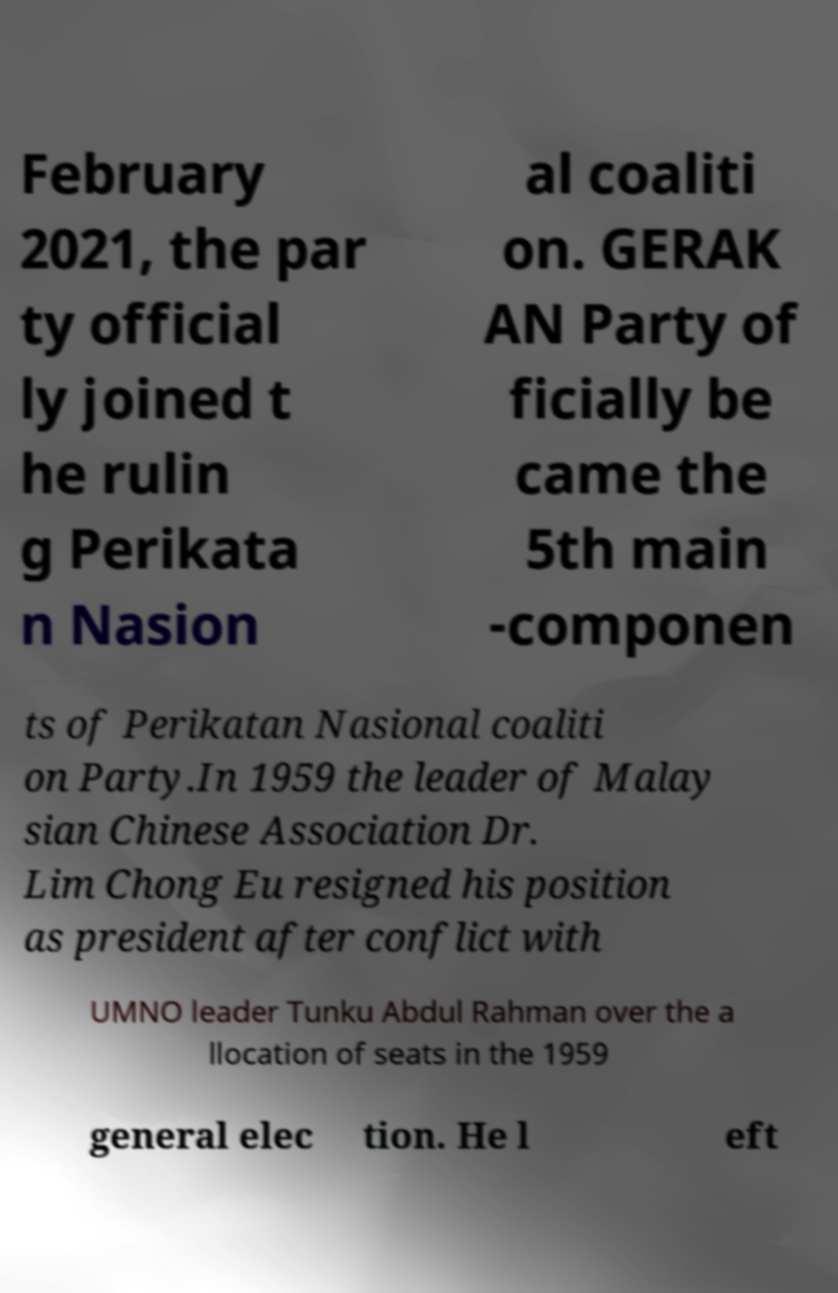Could you assist in decoding the text presented in this image and type it out clearly? February 2021, the par ty official ly joined t he rulin g Perikata n Nasion al coaliti on. GERAK AN Party of ficially be came the 5th main -componen ts of Perikatan Nasional coaliti on Party.In 1959 the leader of Malay sian Chinese Association Dr. Lim Chong Eu resigned his position as president after conflict with UMNO leader Tunku Abdul Rahman over the a llocation of seats in the 1959 general elec tion. He l eft 